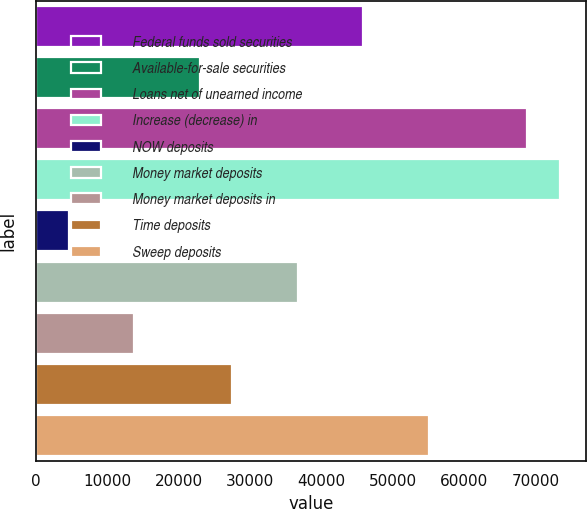Convert chart. <chart><loc_0><loc_0><loc_500><loc_500><bar_chart><fcel>Federal funds sold securities<fcel>Available-for-sale securities<fcel>Loans net of unearned income<fcel>Increase (decrease) in<fcel>NOW deposits<fcel>Money market deposits<fcel>Money market deposits in<fcel>Time deposits<fcel>Sweep deposits<nl><fcel>45886<fcel>22953<fcel>68819<fcel>73405.6<fcel>4606.6<fcel>36712.8<fcel>13779.8<fcel>27539.6<fcel>55059.2<nl></chart> 